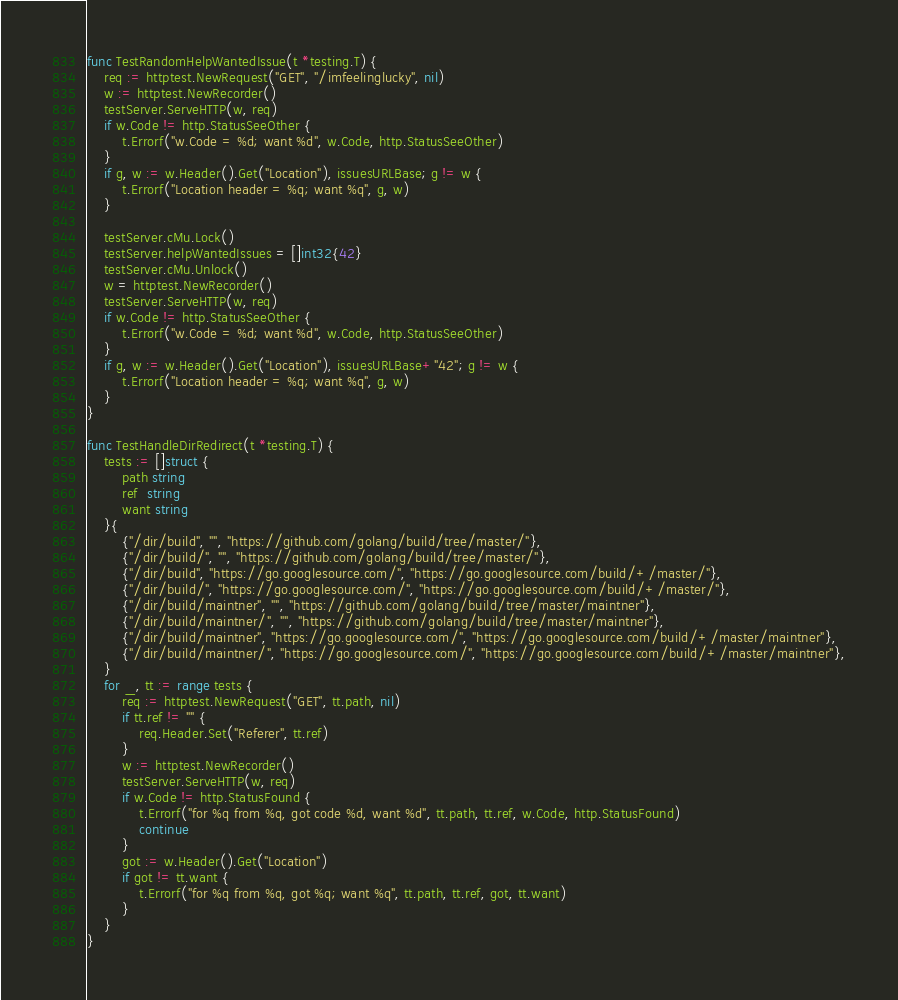<code> <loc_0><loc_0><loc_500><loc_500><_Go_>
func TestRandomHelpWantedIssue(t *testing.T) {
	req := httptest.NewRequest("GET", "/imfeelinglucky", nil)
	w := httptest.NewRecorder()
	testServer.ServeHTTP(w, req)
	if w.Code != http.StatusSeeOther {
		t.Errorf("w.Code = %d; want %d", w.Code, http.StatusSeeOther)
	}
	if g, w := w.Header().Get("Location"), issuesURLBase; g != w {
		t.Errorf("Location header = %q; want %q", g, w)
	}

	testServer.cMu.Lock()
	testServer.helpWantedIssues = []int32{42}
	testServer.cMu.Unlock()
	w = httptest.NewRecorder()
	testServer.ServeHTTP(w, req)
	if w.Code != http.StatusSeeOther {
		t.Errorf("w.Code = %d; want %d", w.Code, http.StatusSeeOther)
	}
	if g, w := w.Header().Get("Location"), issuesURLBase+"42"; g != w {
		t.Errorf("Location header = %q; want %q", g, w)
	}
}

func TestHandleDirRedirect(t *testing.T) {
	tests := []struct {
		path string
		ref  string
		want string
	}{
		{"/dir/build", "", "https://github.com/golang/build/tree/master/"},
		{"/dir/build/", "", "https://github.com/golang/build/tree/master/"},
		{"/dir/build", "https://go.googlesource.com/", "https://go.googlesource.com/build/+/master/"},
		{"/dir/build/", "https://go.googlesource.com/", "https://go.googlesource.com/build/+/master/"},
		{"/dir/build/maintner", "", "https://github.com/golang/build/tree/master/maintner"},
		{"/dir/build/maintner/", "", "https://github.com/golang/build/tree/master/maintner"},
		{"/dir/build/maintner", "https://go.googlesource.com/", "https://go.googlesource.com/build/+/master/maintner"},
		{"/dir/build/maintner/", "https://go.googlesource.com/", "https://go.googlesource.com/build/+/master/maintner"},
	}
	for _, tt := range tests {
		req := httptest.NewRequest("GET", tt.path, nil)
		if tt.ref != "" {
			req.Header.Set("Referer", tt.ref)
		}
		w := httptest.NewRecorder()
		testServer.ServeHTTP(w, req)
		if w.Code != http.StatusFound {
			t.Errorf("for %q from %q, got code %d, want %d", tt.path, tt.ref, w.Code, http.StatusFound)
			continue
		}
		got := w.Header().Get("Location")
		if got != tt.want {
			t.Errorf("for %q from %q, got %q; want %q", tt.path, tt.ref, got, tt.want)
		}
	}
}
</code> 